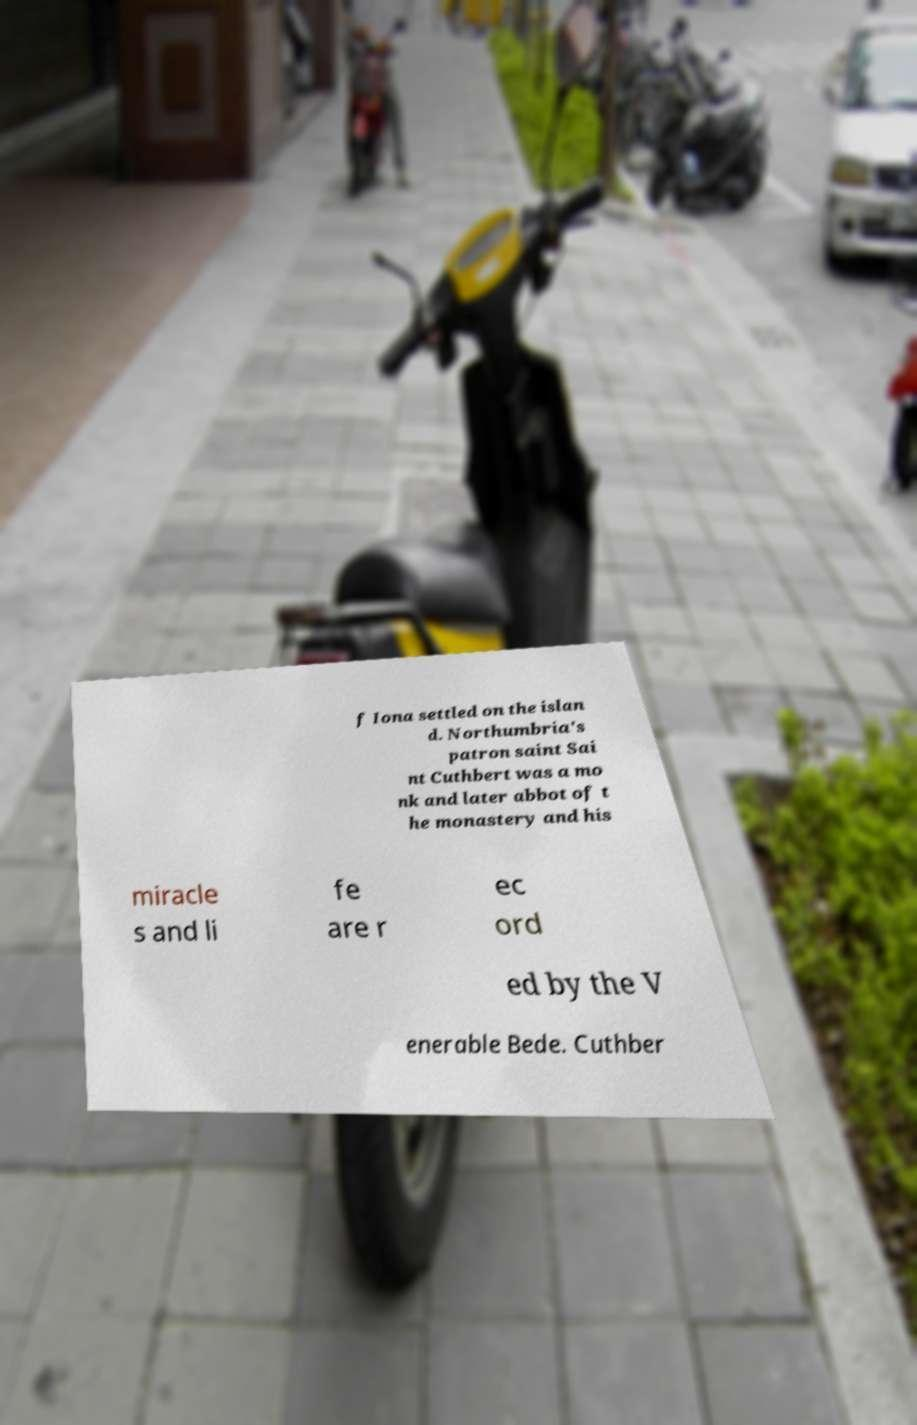Can you read and provide the text displayed in the image?This photo seems to have some interesting text. Can you extract and type it out for me? f Iona settled on the islan d. Northumbria's patron saint Sai nt Cuthbert was a mo nk and later abbot of t he monastery and his miracle s and li fe are r ec ord ed by the V enerable Bede. Cuthber 